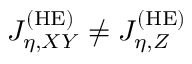<formula> <loc_0><loc_0><loc_500><loc_500>J _ { \eta , X Y } ^ { ( H E ) } \neq J _ { \eta , Z } ^ { ( H E ) }</formula> 